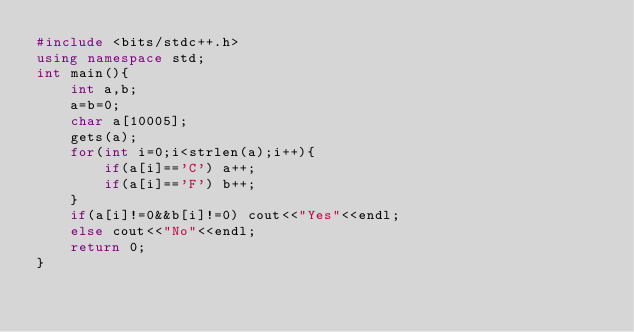<code> <loc_0><loc_0><loc_500><loc_500><_C++_>#include <bits/stdc++.h>
using namespace std;
int main(){
    int a,b;
    a=b=0;
    char a[10005];
    gets(a);
    for(int i=0;i<strlen(a);i++){
        if(a[i]=='C') a++;
        if(a[i]=='F') b++;
    }
    if(a[i]!=0&&b[i]!=0) cout<<"Yes"<<endl;
    else cout<<"No"<<endl;
    return 0;
}</code> 